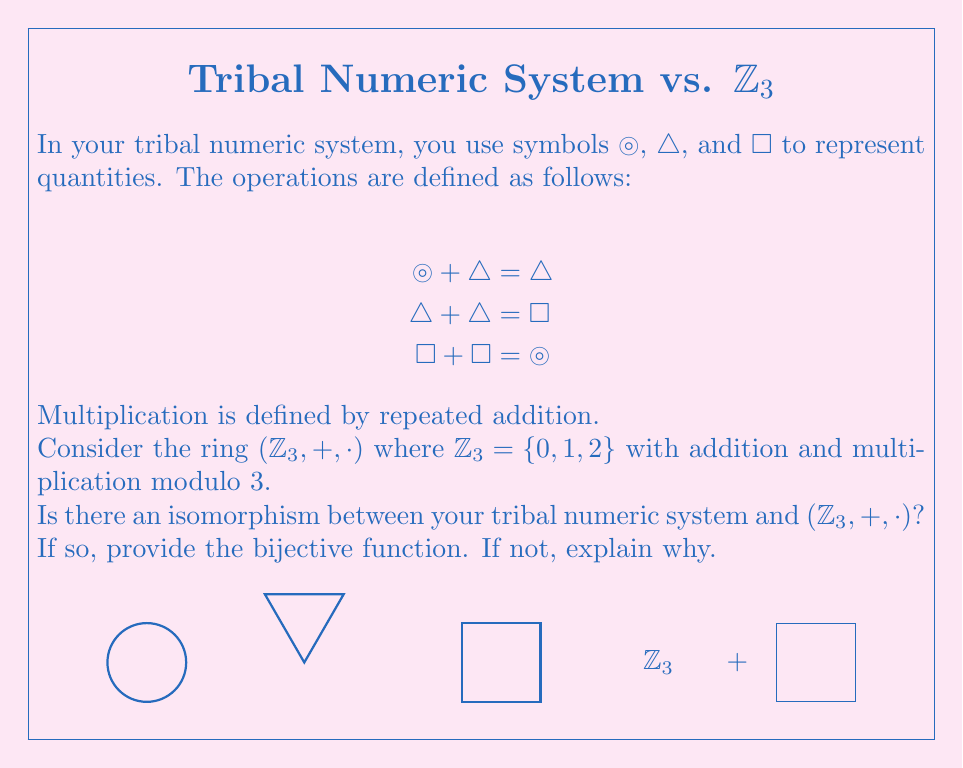Help me with this question. To determine if there's an isomorphism between the tribal numeric system and $(\mathbb{Z}_3, +, \cdot)$, we need to check if there's a bijective function that preserves the operations.

Step 1: Identify the elements and operations in both systems.
Tribal system: {◯, △, ☐}
$\mathbb{Z}_3$: {0, 1, 2}

Step 2: Check if the number of elements is the same.
Both systems have 3 elements, so a bijection is possible.

Step 3: Define a potential bijective function $f$:
$f(◯) = 0$
$f(△) = 1$
$f(☐) = 2$

Step 4: Verify if the addition operation is preserved.
In the tribal system:
◯ + △ = △  $\rightarrow$  $f(◯) + f(△) = f(△)$  $\rightarrow$  $0 + 1 \equiv 1 \pmod{3}$
△ + △ = ☐  $\rightarrow$  $f(△) + f(△) = f(☐)$  $\rightarrow$  $1 + 1 \equiv 2 \pmod{3}$
☐ + ☐ = ◯  $\rightarrow$  $f(☐) + f(☐) = f(◯)$  $\rightarrow$  $2 + 2 \equiv 0 \pmod{3}$

Step 5: Verify if the multiplication operation is preserved.
In the tribal system, multiplication is defined by repeated addition. Let's check:
△ · △ = △ + △ = ☐  $\rightarrow$  $f(△) \cdot f(△) = f(☐)$  $\rightarrow$  $1 \cdot 1 \equiv 2 \pmod{3}$
△ · ☐ = △ + △ + △ = △  $\rightarrow$  $f(△) \cdot f(☐) = f(△)$  $\rightarrow$  $1 \cdot 2 \equiv 1 \pmod{3}$

Step 6: Conclusion
The bijective function $f$ preserves both addition and multiplication operations. Therefore, there is an isomorphism between the tribal numeric system and $(\mathbb{Z}_3, +, \cdot)$.
Answer: Yes, $f(◯) = 0$, $f(△) = 1$, $f(☐) = 2$ 